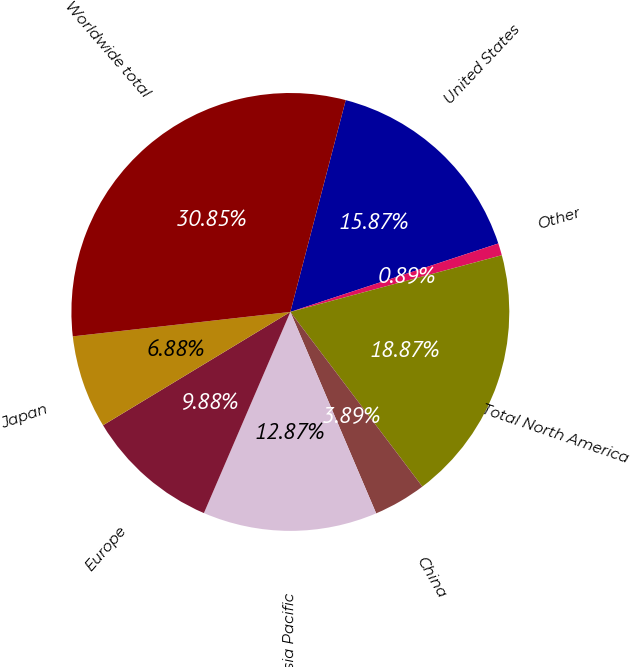<chart> <loc_0><loc_0><loc_500><loc_500><pie_chart><fcel>United States<fcel>Other<fcel>Total North America<fcel>China<fcel>Total Asia Pacific<fcel>Europe<fcel>Japan<fcel>Worldwide total<nl><fcel>15.87%<fcel>0.89%<fcel>18.87%<fcel>3.89%<fcel>12.87%<fcel>9.88%<fcel>6.88%<fcel>30.85%<nl></chart> 